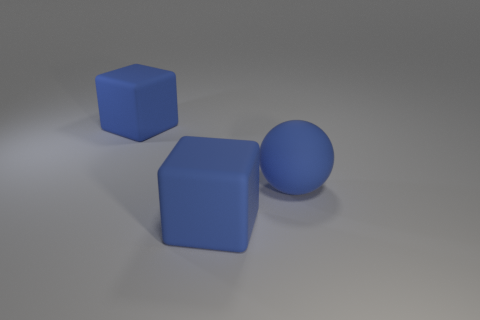Add 2 yellow spheres. How many objects exist? 5 Subtract all balls. How many objects are left? 2 Subtract 1 spheres. How many spheres are left? 0 Add 3 large blue balls. How many large blue balls exist? 4 Subtract 0 green cylinders. How many objects are left? 3 Subtract all purple blocks. Subtract all blue spheres. How many blocks are left? 2 Subtract all large balls. Subtract all small shiny cubes. How many objects are left? 2 Add 1 blue rubber cubes. How many blue rubber cubes are left? 3 